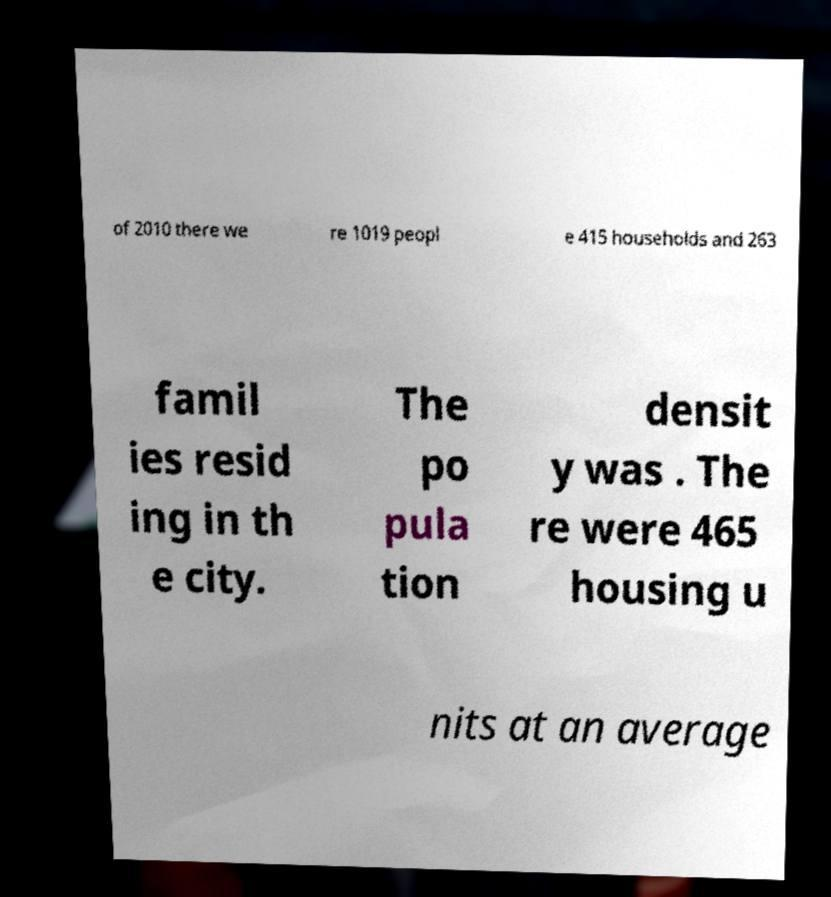There's text embedded in this image that I need extracted. Can you transcribe it verbatim? of 2010 there we re 1019 peopl e 415 households and 263 famil ies resid ing in th e city. The po pula tion densit y was . The re were 465 housing u nits at an average 